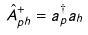Convert formula to latex. <formula><loc_0><loc_0><loc_500><loc_500>\hat { A } ^ { + } _ { p h } = a ^ { \dagger } _ { p } a _ { h }</formula> 